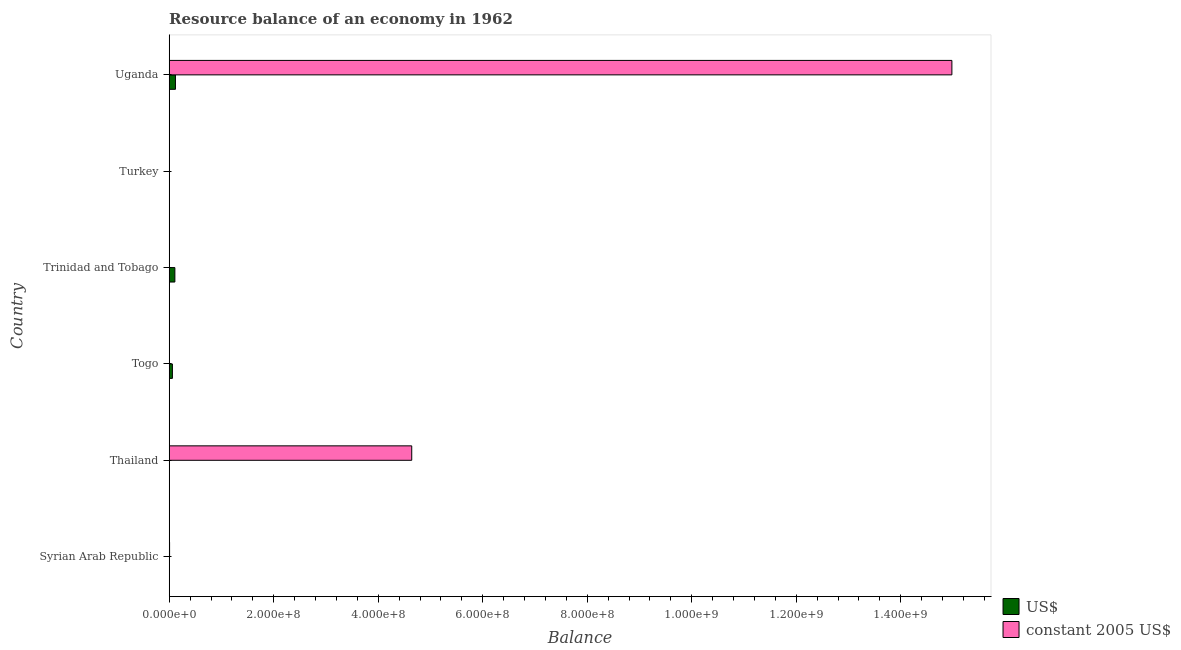How many different coloured bars are there?
Your answer should be compact. 2. How many bars are there on the 4th tick from the top?
Your answer should be very brief. 1. How many bars are there on the 3rd tick from the bottom?
Make the answer very short. 1. In how many cases, is the number of bars for a given country not equal to the number of legend labels?
Make the answer very short. 5. What is the resource balance in us$ in Trinidad and Tobago?
Make the answer very short. 1.08e+07. Across all countries, what is the maximum resource balance in us$?
Keep it short and to the point. 1.19e+07. In which country was the resource balance in constant us$ maximum?
Ensure brevity in your answer.  Uganda. What is the total resource balance in us$ in the graph?
Offer a very short reply. 2.89e+07. What is the difference between the resource balance in constant us$ in Syrian Arab Republic and that in Uganda?
Provide a short and direct response. -1.50e+09. What is the difference between the resource balance in constant us$ in Trinidad and Tobago and the resource balance in us$ in Uganda?
Your response must be concise. -1.19e+07. What is the average resource balance in us$ per country?
Provide a short and direct response. 4.82e+06. What is the difference between the resource balance in constant us$ and resource balance in us$ in Uganda?
Give a very brief answer. 1.49e+09. In how many countries, is the resource balance in us$ greater than 1040000000 units?
Your response must be concise. 0. What is the difference between the highest and the second highest resource balance in us$?
Provide a short and direct response. 1.10e+06. What is the difference between the highest and the lowest resource balance in constant us$?
Keep it short and to the point. 1.50e+09. Is the sum of the resource balance in constant us$ in Thailand and Uganda greater than the maximum resource balance in us$ across all countries?
Give a very brief answer. Yes. Are all the bars in the graph horizontal?
Provide a succinct answer. Yes. What is the difference between two consecutive major ticks on the X-axis?
Provide a short and direct response. 2.00e+08. Are the values on the major ticks of X-axis written in scientific E-notation?
Give a very brief answer. Yes. Does the graph contain any zero values?
Make the answer very short. Yes. How are the legend labels stacked?
Provide a succinct answer. Vertical. What is the title of the graph?
Provide a succinct answer. Resource balance of an economy in 1962. What is the label or title of the X-axis?
Make the answer very short. Balance. What is the label or title of the Y-axis?
Offer a very short reply. Country. What is the Balance of constant 2005 US$ in Syrian Arab Republic?
Your answer should be very brief. 7.00e+05. What is the Balance in constant 2005 US$ in Thailand?
Provide a short and direct response. 4.64e+08. What is the Balance in US$ in Togo?
Give a very brief answer. 6.11e+06. What is the Balance in constant 2005 US$ in Togo?
Your answer should be compact. 0. What is the Balance of US$ in Trinidad and Tobago?
Your answer should be very brief. 1.08e+07. What is the Balance of constant 2005 US$ in Trinidad and Tobago?
Your response must be concise. 0. What is the Balance in constant 2005 US$ in Turkey?
Offer a terse response. 0. What is the Balance in US$ in Uganda?
Ensure brevity in your answer.  1.19e+07. What is the Balance of constant 2005 US$ in Uganda?
Your response must be concise. 1.50e+09. Across all countries, what is the maximum Balance in US$?
Offer a terse response. 1.19e+07. Across all countries, what is the maximum Balance in constant 2005 US$?
Provide a short and direct response. 1.50e+09. Across all countries, what is the minimum Balance in US$?
Make the answer very short. 0. Across all countries, what is the minimum Balance of constant 2005 US$?
Give a very brief answer. 0. What is the total Balance in US$ in the graph?
Your response must be concise. 2.89e+07. What is the total Balance of constant 2005 US$ in the graph?
Ensure brevity in your answer.  1.96e+09. What is the difference between the Balance in constant 2005 US$ in Syrian Arab Republic and that in Thailand?
Provide a succinct answer. -4.63e+08. What is the difference between the Balance of constant 2005 US$ in Syrian Arab Republic and that in Uganda?
Offer a terse response. -1.50e+09. What is the difference between the Balance in constant 2005 US$ in Thailand and that in Uganda?
Keep it short and to the point. -1.03e+09. What is the difference between the Balance of US$ in Togo and that in Trinidad and Tobago?
Give a very brief answer. -4.74e+06. What is the difference between the Balance in US$ in Togo and that in Uganda?
Your response must be concise. -5.83e+06. What is the difference between the Balance of US$ in Trinidad and Tobago and that in Uganda?
Provide a succinct answer. -1.10e+06. What is the difference between the Balance in US$ in Togo and the Balance in constant 2005 US$ in Uganda?
Ensure brevity in your answer.  -1.49e+09. What is the difference between the Balance of US$ in Trinidad and Tobago and the Balance of constant 2005 US$ in Uganda?
Provide a short and direct response. -1.49e+09. What is the average Balance of US$ per country?
Offer a terse response. 4.82e+06. What is the average Balance in constant 2005 US$ per country?
Your answer should be compact. 3.27e+08. What is the difference between the Balance of US$ and Balance of constant 2005 US$ in Uganda?
Offer a very short reply. -1.49e+09. What is the ratio of the Balance in constant 2005 US$ in Syrian Arab Republic to that in Thailand?
Provide a short and direct response. 0. What is the ratio of the Balance in constant 2005 US$ in Syrian Arab Republic to that in Uganda?
Your answer should be compact. 0. What is the ratio of the Balance in constant 2005 US$ in Thailand to that in Uganda?
Ensure brevity in your answer.  0.31. What is the ratio of the Balance of US$ in Togo to that in Trinidad and Tobago?
Give a very brief answer. 0.56. What is the ratio of the Balance of US$ in Togo to that in Uganda?
Ensure brevity in your answer.  0.51. What is the ratio of the Balance of US$ in Trinidad and Tobago to that in Uganda?
Your answer should be very brief. 0.91. What is the difference between the highest and the second highest Balance of US$?
Your response must be concise. 1.10e+06. What is the difference between the highest and the second highest Balance in constant 2005 US$?
Make the answer very short. 1.03e+09. What is the difference between the highest and the lowest Balance in US$?
Provide a succinct answer. 1.19e+07. What is the difference between the highest and the lowest Balance in constant 2005 US$?
Your answer should be compact. 1.50e+09. 